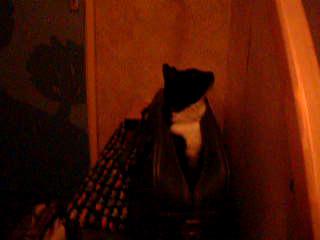The cat is in the luggage?
Keep it brief. Yes. What animal is in the luggage?
Write a very short answer. Cat. What are the cats looking at?
Concise answer only. Wall. Where is the cat looking?
Be succinct. Up. 